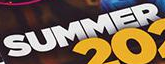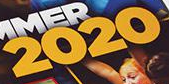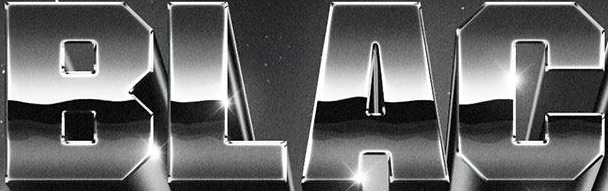What words can you see in these images in sequence, separated by a semicolon? SUMMER; 2020; BLAC 